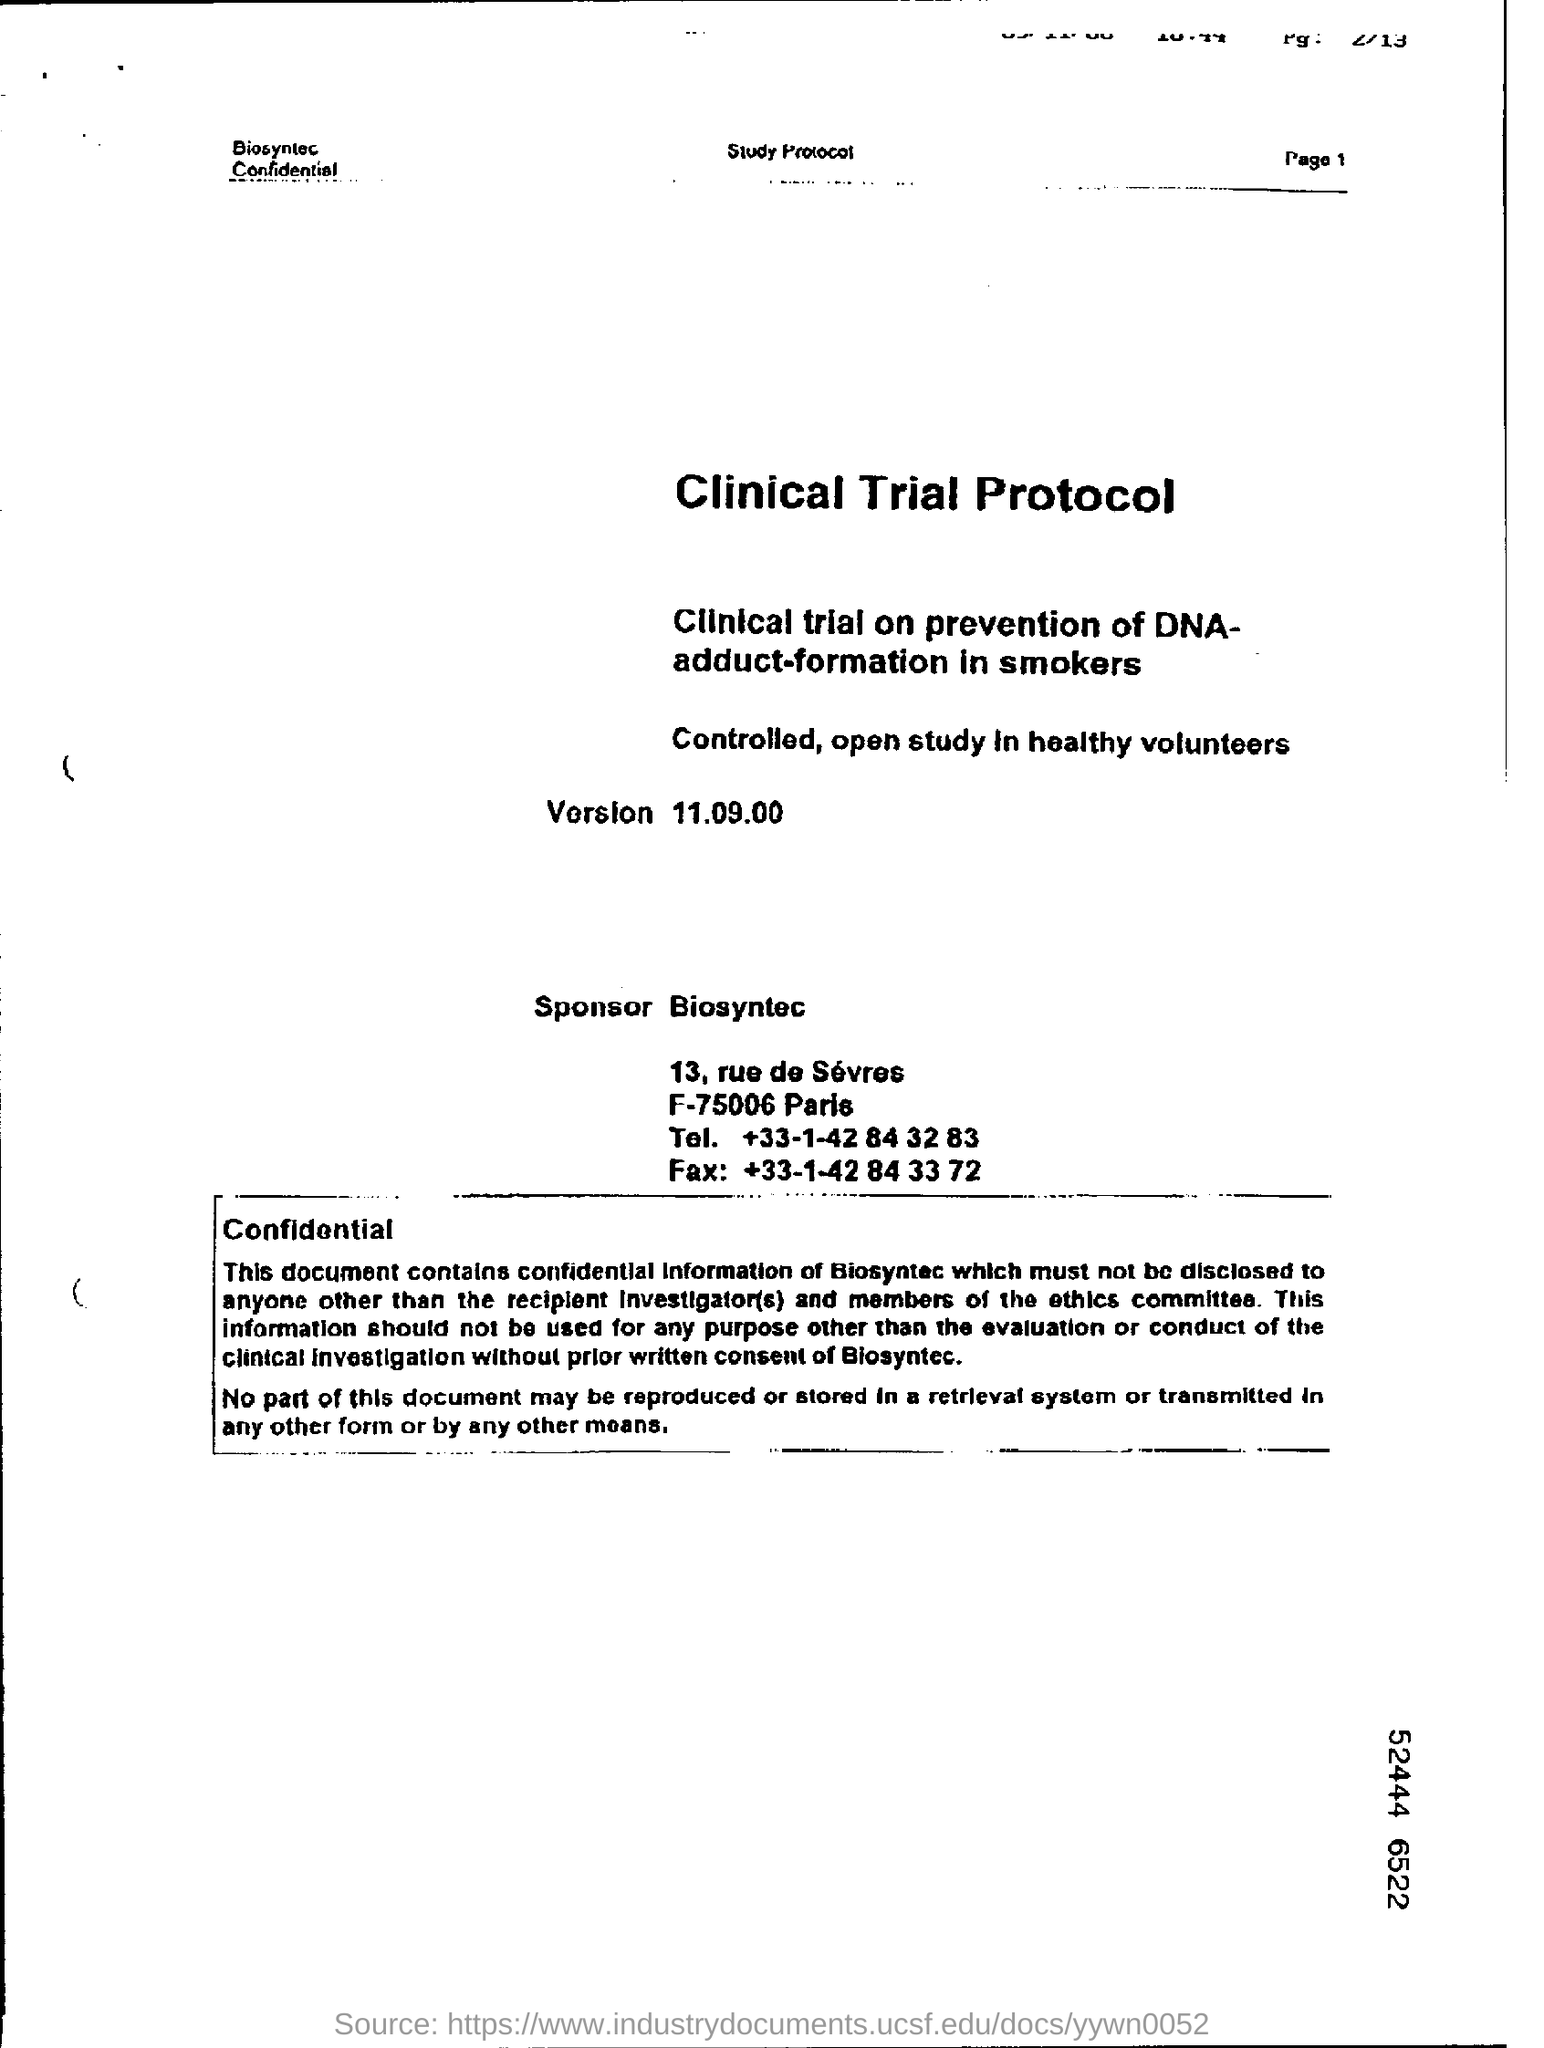Mention the page number at top right corner of the page ?
Provide a short and direct response. 1. 